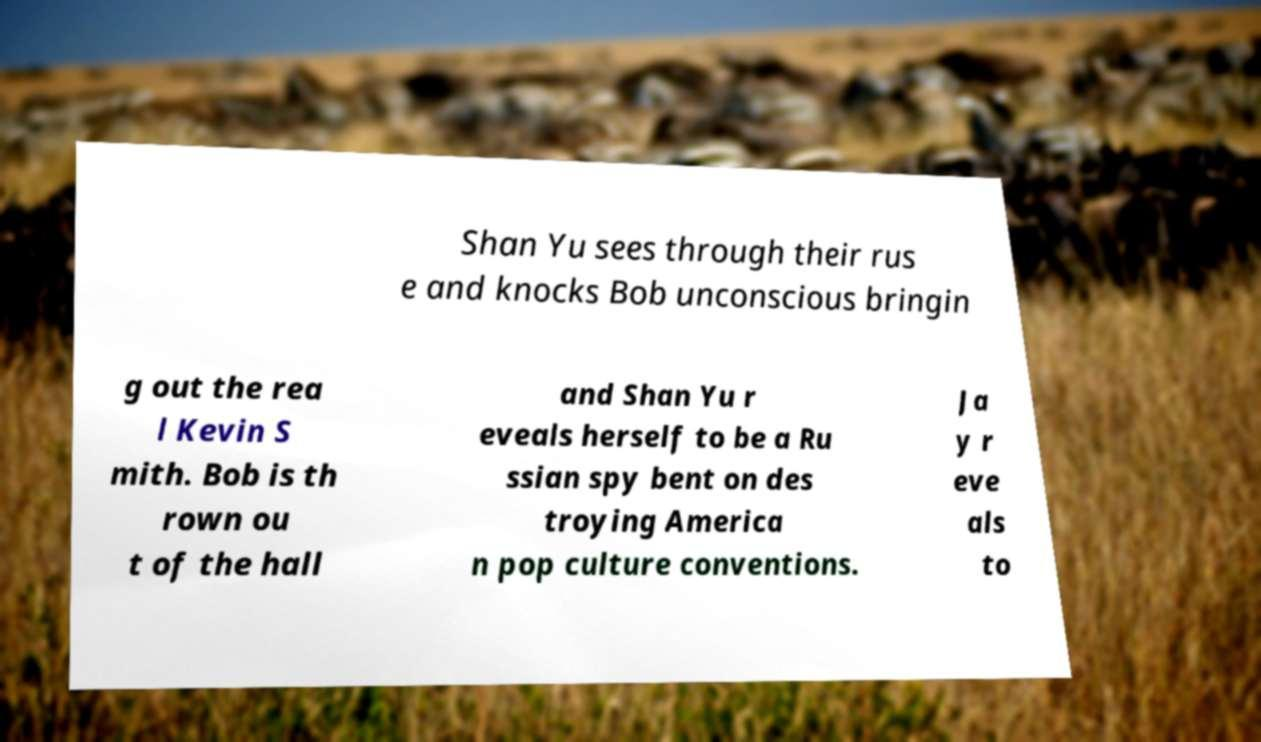Please read and relay the text visible in this image. What does it say? Shan Yu sees through their rus e and knocks Bob unconscious bringin g out the rea l Kevin S mith. Bob is th rown ou t of the hall and Shan Yu r eveals herself to be a Ru ssian spy bent on des troying America n pop culture conventions. Ja y r eve als to 